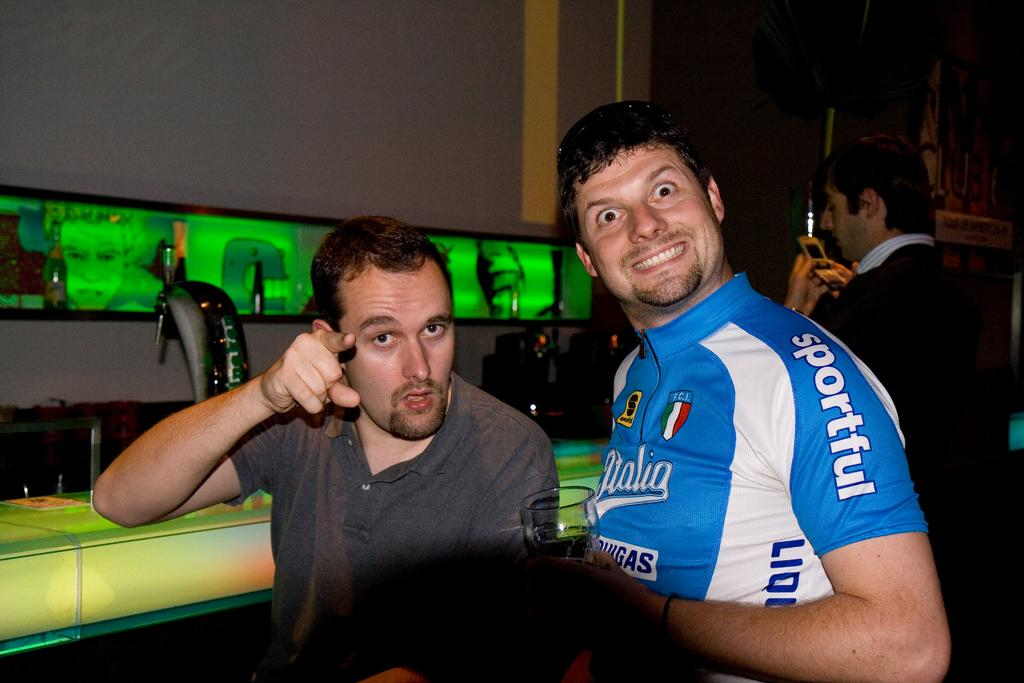How many people are in the image? There are three men in the image. What can be seen on the left side of the image? There are electronic displays with lights on the left side of the image. What type of objects are present in the image? There are machines in the image. What type of potato is being served at the party in the image? There is no party or potato present in the image. Who is the father of the men in the image? The provided facts do not mention any information about the men's parents, so it cannot be determined from the image. 